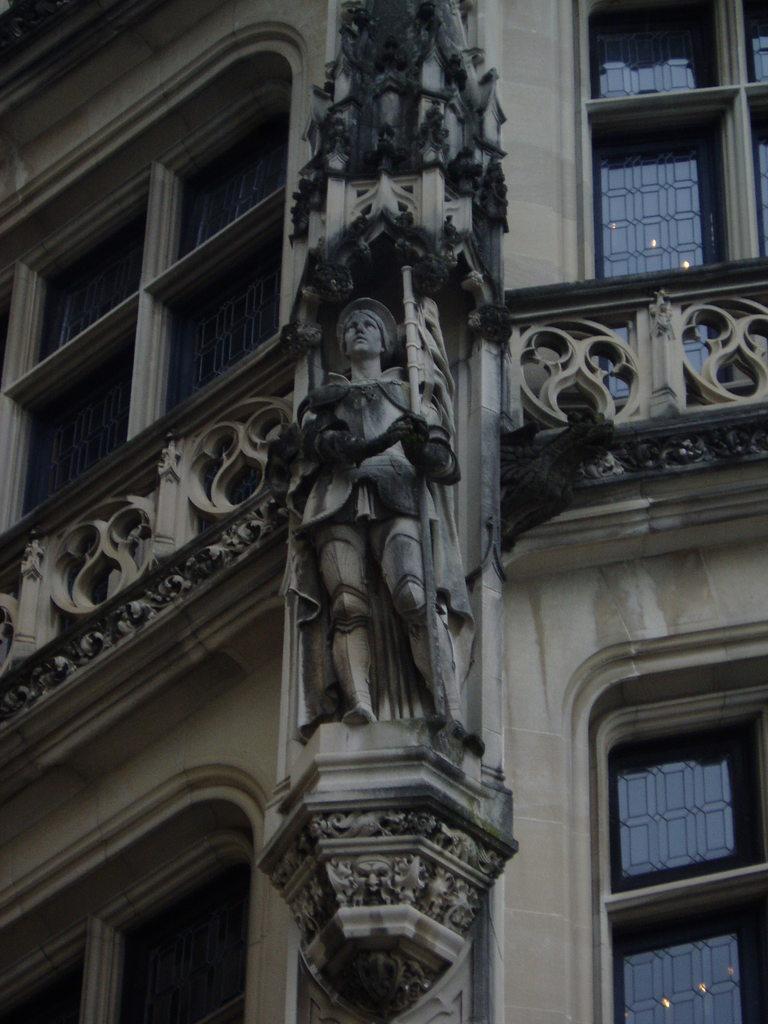In one or two sentences, can you explain what this image depicts? In this image we can see a building, on the building, we can see a statue, there are some windows. 